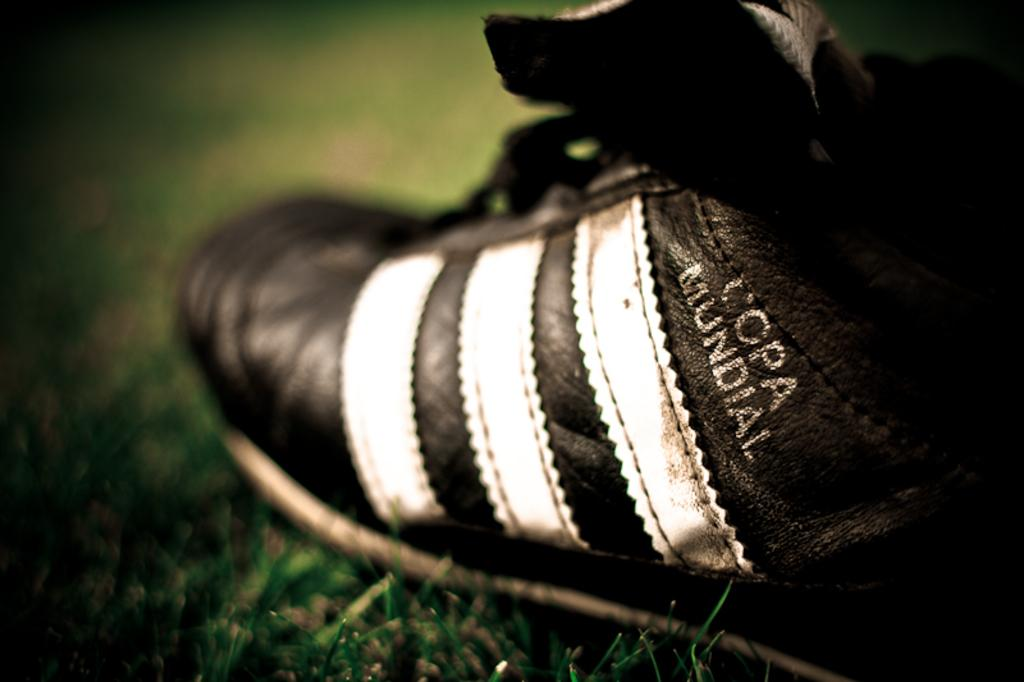What type of footwear is visible in the image? There is a black shoe in the image. Where is the black shoe located? The black shoe is on the grassland. What type of glove is being used to balance on the black shoe in the image? There is no glove or balancing act present in the image; it only features a black shoe on the grassland. 